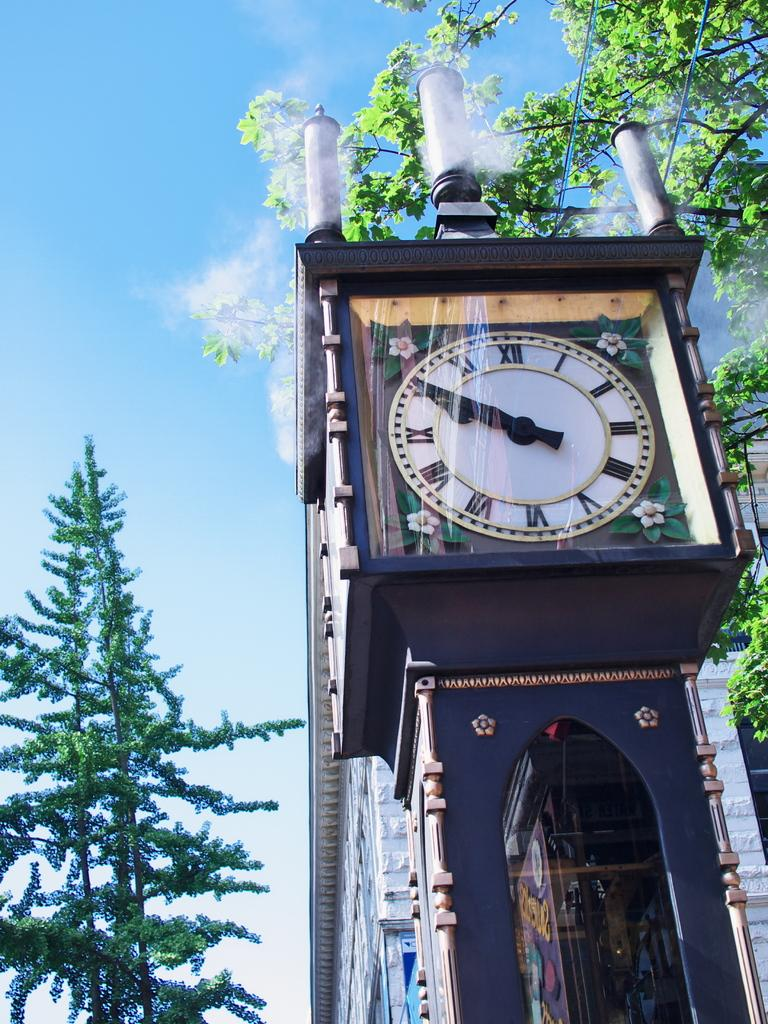<image>
Offer a succinct explanation of the picture presented. On a beautiful, sunny day, a large clock tower displays 9:50. 